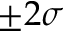Convert formula to latex. <formula><loc_0><loc_0><loc_500><loc_500>\pm 2 \sigma</formula> 